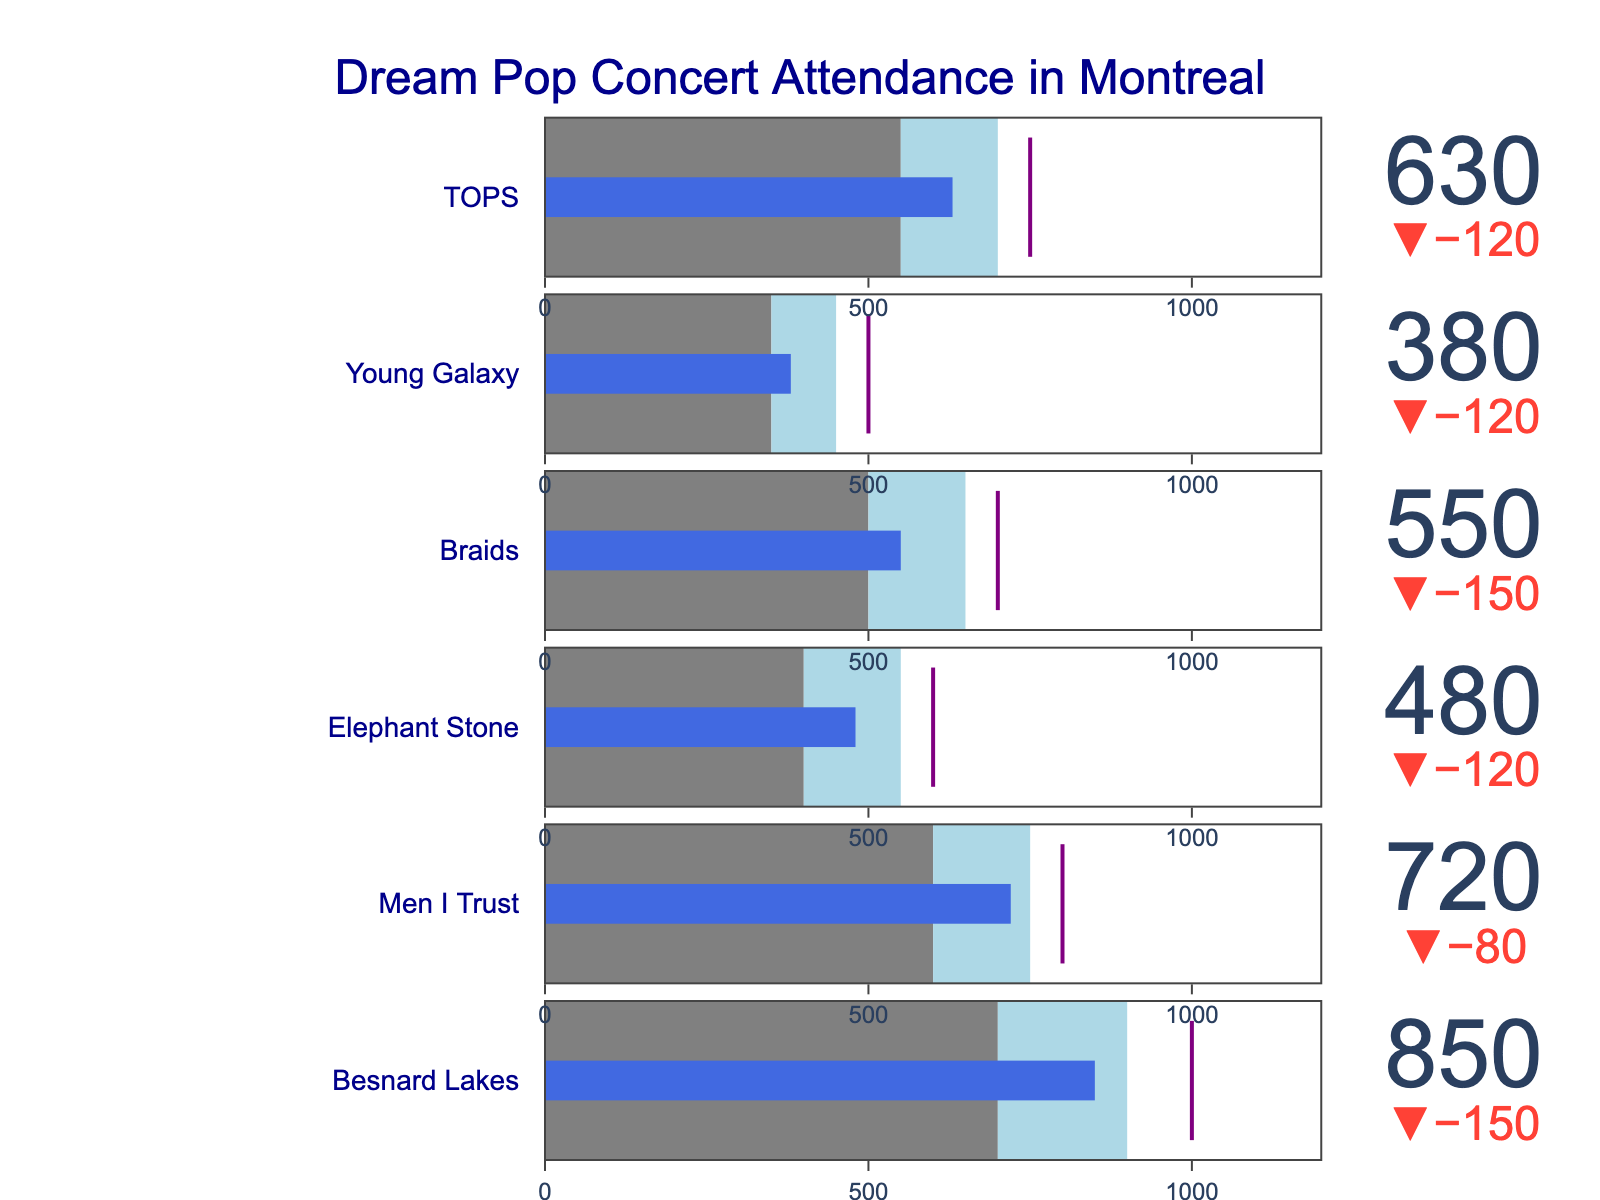What is the title of the figure? The title is generally placed at the top of the figure and is easily readable.
Answer: Dream Pop Concert Attendance in Montreal Which band had the highest actual attendance? By looking at the actual attendance values for each band, the highest one is 850.
Answer: Besnard Lakes How many bands did not meet their target attendance? By comparing the actual attendance to the target attendance for each band, count the number of bands where actual < target. There are six bands listed, and all have actual attendance less than target.
Answer: 6 What is the difference between actual and target attendance for Young Galaxy? Subtract the actual attendance from the target (500 - 380).
Answer: 120 Which band had the smallest gap between their actual attendance and target? Calculate the differences between actual and target for all bands and find the smallest. Braids (700 - 550) = 150 is the smallest among all the bands.
Answer: Braids For which band did the actual attendance fall into the satisfactory range? Compare the actual attendance value for each band with their satisfactory range, the range where Poor < Actual < Satisfactory. For Men I Trust, the actual attendance (720) is within the range (600, 750).
Answer: Men I Trust Which bands had their actual attendance in the 'Good' range? Compare each band's actual attendance to their Good range. No bands had attendance values within their Good range.
Answer: None How does the actual attendance for the band TOPS compare to the satisfactory range? Check where TOPS's actual attendance (630) falls in relation to its satisfactory range (550 to 700).
Answer: Within satisfactory What is the average target attendance for all the bands? Sum up all target values and divide by the number of bands: (1000 + 800 + 600 + 700 + 500 + 750) / 6 = 4350 / 6
Answer: 725 